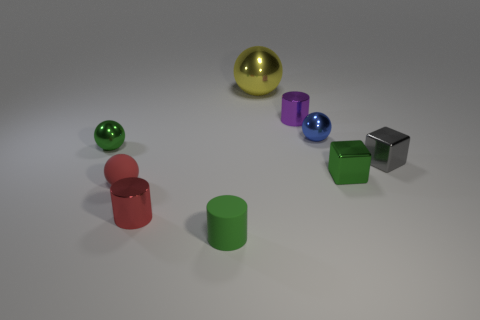Is there any other thing that is the same size as the yellow ball?
Your answer should be very brief. No. Are there any green blocks made of the same material as the red ball?
Give a very brief answer. No. There is a shiny thing right of the green block; what is its color?
Your answer should be compact. Gray. Do the purple shiny thing and the small red metal object in front of the yellow metal sphere have the same shape?
Give a very brief answer. Yes. Are there any small metallic cylinders that have the same color as the small rubber sphere?
Provide a succinct answer. Yes. There is a green block that is made of the same material as the tiny blue object; what is its size?
Keep it short and to the point. Small. Do the small matte object that is on the left side of the green rubber cylinder and the gray object have the same shape?
Your response must be concise. No. What number of metal balls have the same size as the red rubber ball?
Offer a terse response. 2. There is a metallic ball that is behind the tiny purple metal cylinder; are there any tiny green metal objects on the right side of it?
Your answer should be compact. Yes. What number of objects are either green objects behind the small green matte cylinder or small objects?
Your answer should be very brief. 8. 